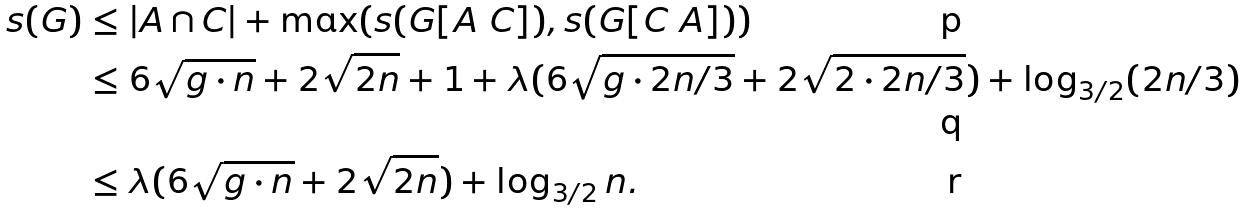<formula> <loc_0><loc_0><loc_500><loc_500>s ( G ) & \leq | A \cap C | + \max ( s ( G [ A \ C ] ) , s ( G [ C \ A ] ) ) \\ & \leq 6 \sqrt { g \cdot n } + 2 \sqrt { 2 n } + 1 + \lambda ( 6 \sqrt { g \cdot 2 n / 3 } + 2 \sqrt { 2 \cdot 2 n / 3 } ) + \log _ { 3 / 2 } ( 2 n / 3 ) \\ & \leq \lambda ( 6 \sqrt { g \cdot n } + 2 \sqrt { 2 n } ) + \log _ { 3 / 2 } n .</formula> 